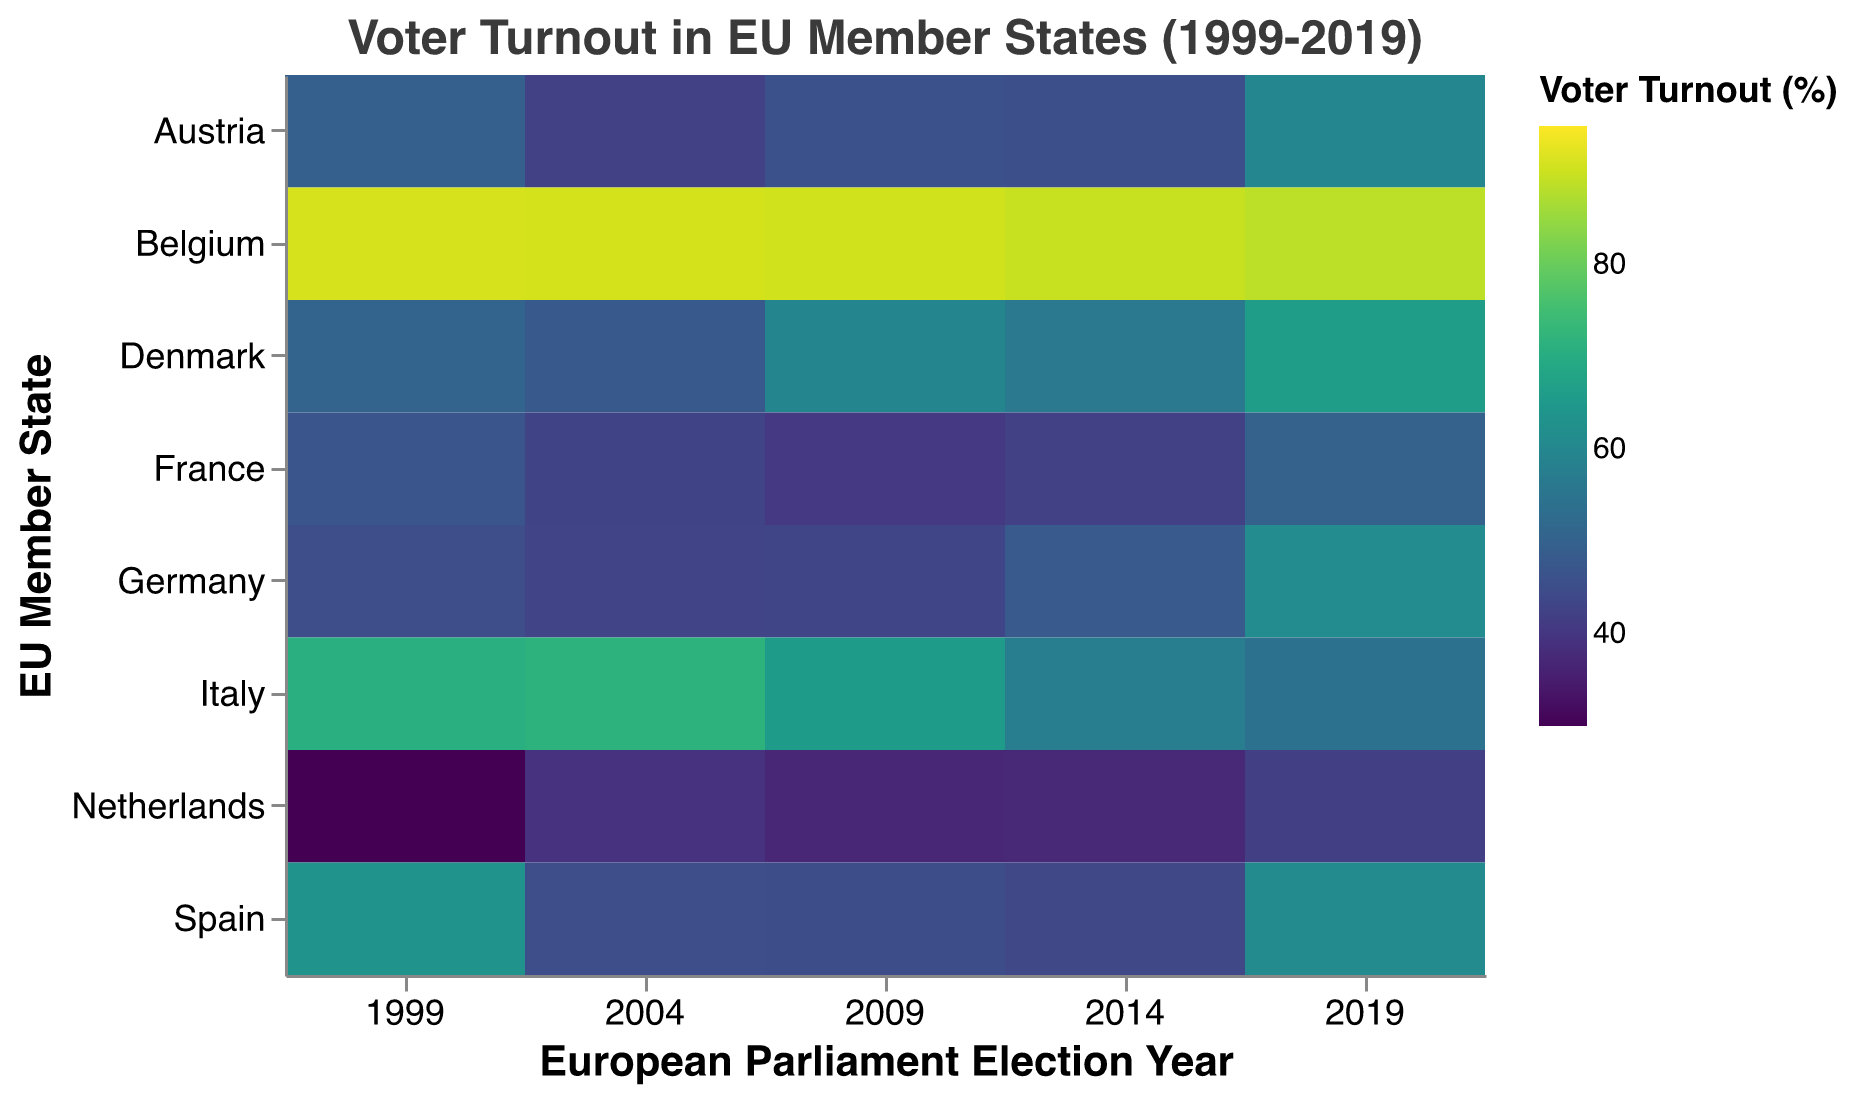How does voter turnout in Belgium in 2019 compare to other years? Belgium's voter turnout in 2019 can be noted on the heatmap as 88.5%. Comparing this to previous years: 2014 (89.6%), 2009 (90.4%), 2004 (90.8%), and 1999 (91.0%), we see a gradual decline. It indicates that turnout in 2019 is lower than all the previous years on record.
Answer: It is lower Which EU member state had the highest voter turnout in 2019? By examining the color intensity in the heatmap for the year 2019, Belgium's square stands out with the highest value of 88.5%. This value is visibly darker compared to other countries for the same year.
Answer: Belgium How did voter turnout in the Netherlands change from 1999 to 2019? Observing the heatmap, the voter turnout in the Netherlands in 1999 was 30.0% and increased to 41.9% in 2019. This change indicates a rise.
Answer: It increased What was the lowest voter turnout observed in Germany over the five election years? The color gradient in the heatmap for Germany is crucial here. For years 1999, 45.2%; 2004, 43.0%; 2009, 43.3%; 2014, 48.1%; 2019, 61.4%. The year 2004 has the lowest turnout at 43.0%.
Answer: 43.0% in 2004 Compare voter turnout trends for Italy and Spain. By analyzing the heatmap, between 1999, 2004, and 2009, Italy shows decreasing turnout from 70.8% to 65.5%. Meanwhile, Spain's turnout fell from 63.0% in 1999 to around 45% in 2004-2009, then rose to 60.7% in 2019, showcasing a more varied pattern compared to Italy's consistent decline and small rebound to 54.5% in 2019.
Answer: Italy has a consistent decline; Spain shows more variation Which country experienced the most significant increase in voter turnout from 2014 to 2019? Compare color gradients between 2014 and 2019. Spain's turnout went from 43.8% in 2014 to 60.7% in 2019, the most substantial increase among all countries considered.
Answer: Spain Identify two countries where voter turnout in 2014 was lower than in 2009. From the heatmap, comparing colors for each country between 2014 and 2009, Germany (48.1% vs. 43.3%) and Spain (43.8% vs. 44.9%) show that voter turnout was lower in 2014 than in 2009.
Answer: Germany and Spain What is the general voter turnout pattern in Denmark from 1999 to 2019? Observing Denmark on the heatmap, the turnout was 50.5% in 1999, increased to 66.1% in 2019, with some fluctuations in between (47.9% and up). The general pattern is an increasing trend.
Answer: It increased overall Which country had a consistently high voter turnout over all the years? Belgium's heatmap square consistently shows dark color intensity across all election years (1999-2019), indicating a high voter turnout through all the recorded years.
Answer: Belgium 